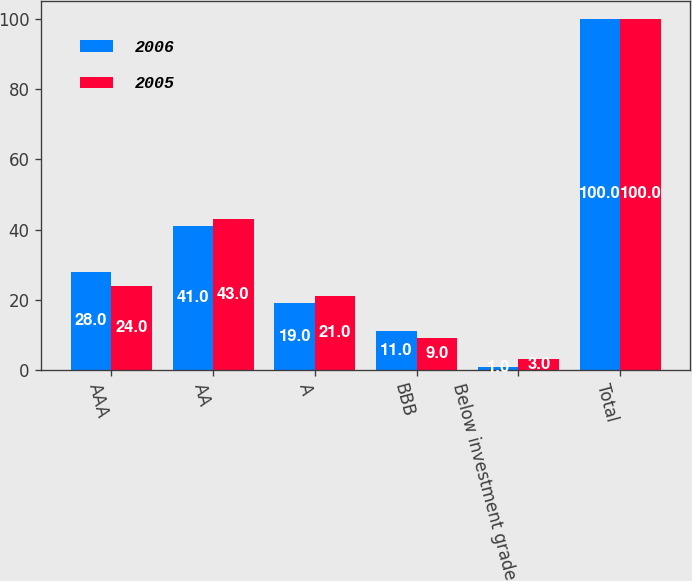<chart> <loc_0><loc_0><loc_500><loc_500><stacked_bar_chart><ecel><fcel>AAA<fcel>AA<fcel>A<fcel>BBB<fcel>Below investment grade<fcel>Total<nl><fcel>2006<fcel>28<fcel>41<fcel>19<fcel>11<fcel>1<fcel>100<nl><fcel>2005<fcel>24<fcel>43<fcel>21<fcel>9<fcel>3<fcel>100<nl></chart> 